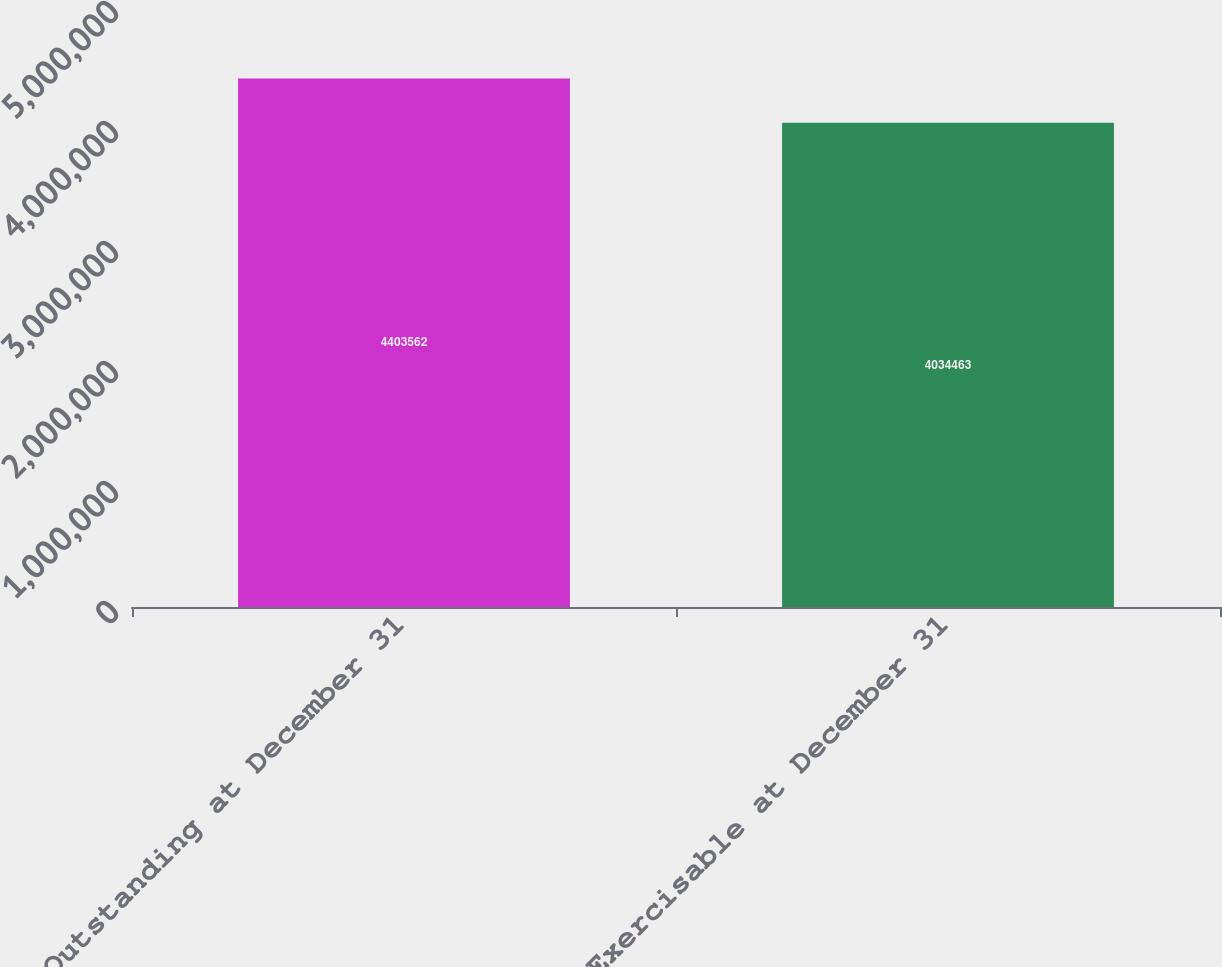Convert chart. <chart><loc_0><loc_0><loc_500><loc_500><bar_chart><fcel>Outstanding at December 31<fcel>Exercisable at December 31<nl><fcel>4.40356e+06<fcel>4.03446e+06<nl></chart> 